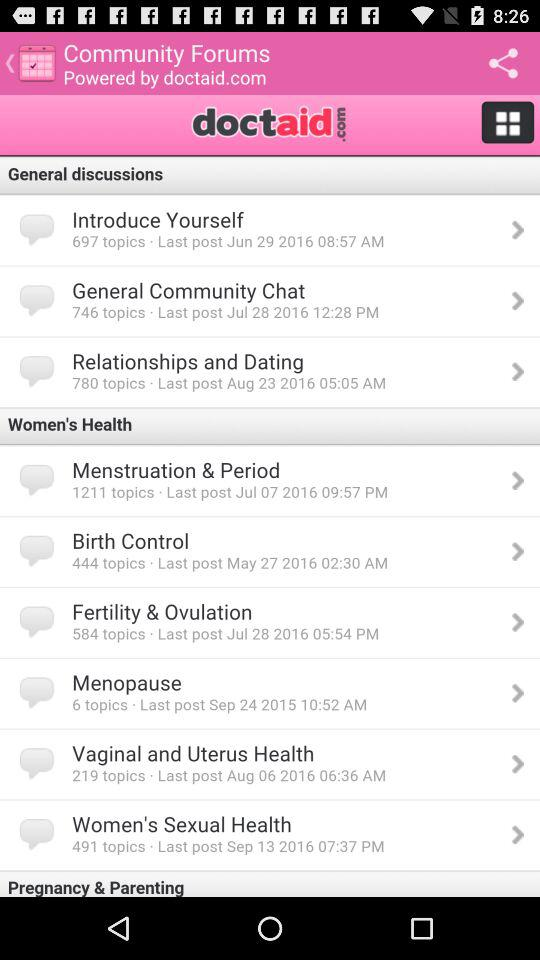What is the posted date and time of the last topic posted in "General Community Chat"? The posted date and time of the last topic posted in "General Community Chat" are July 28, 2016 at 12:28 PM, respectively. 